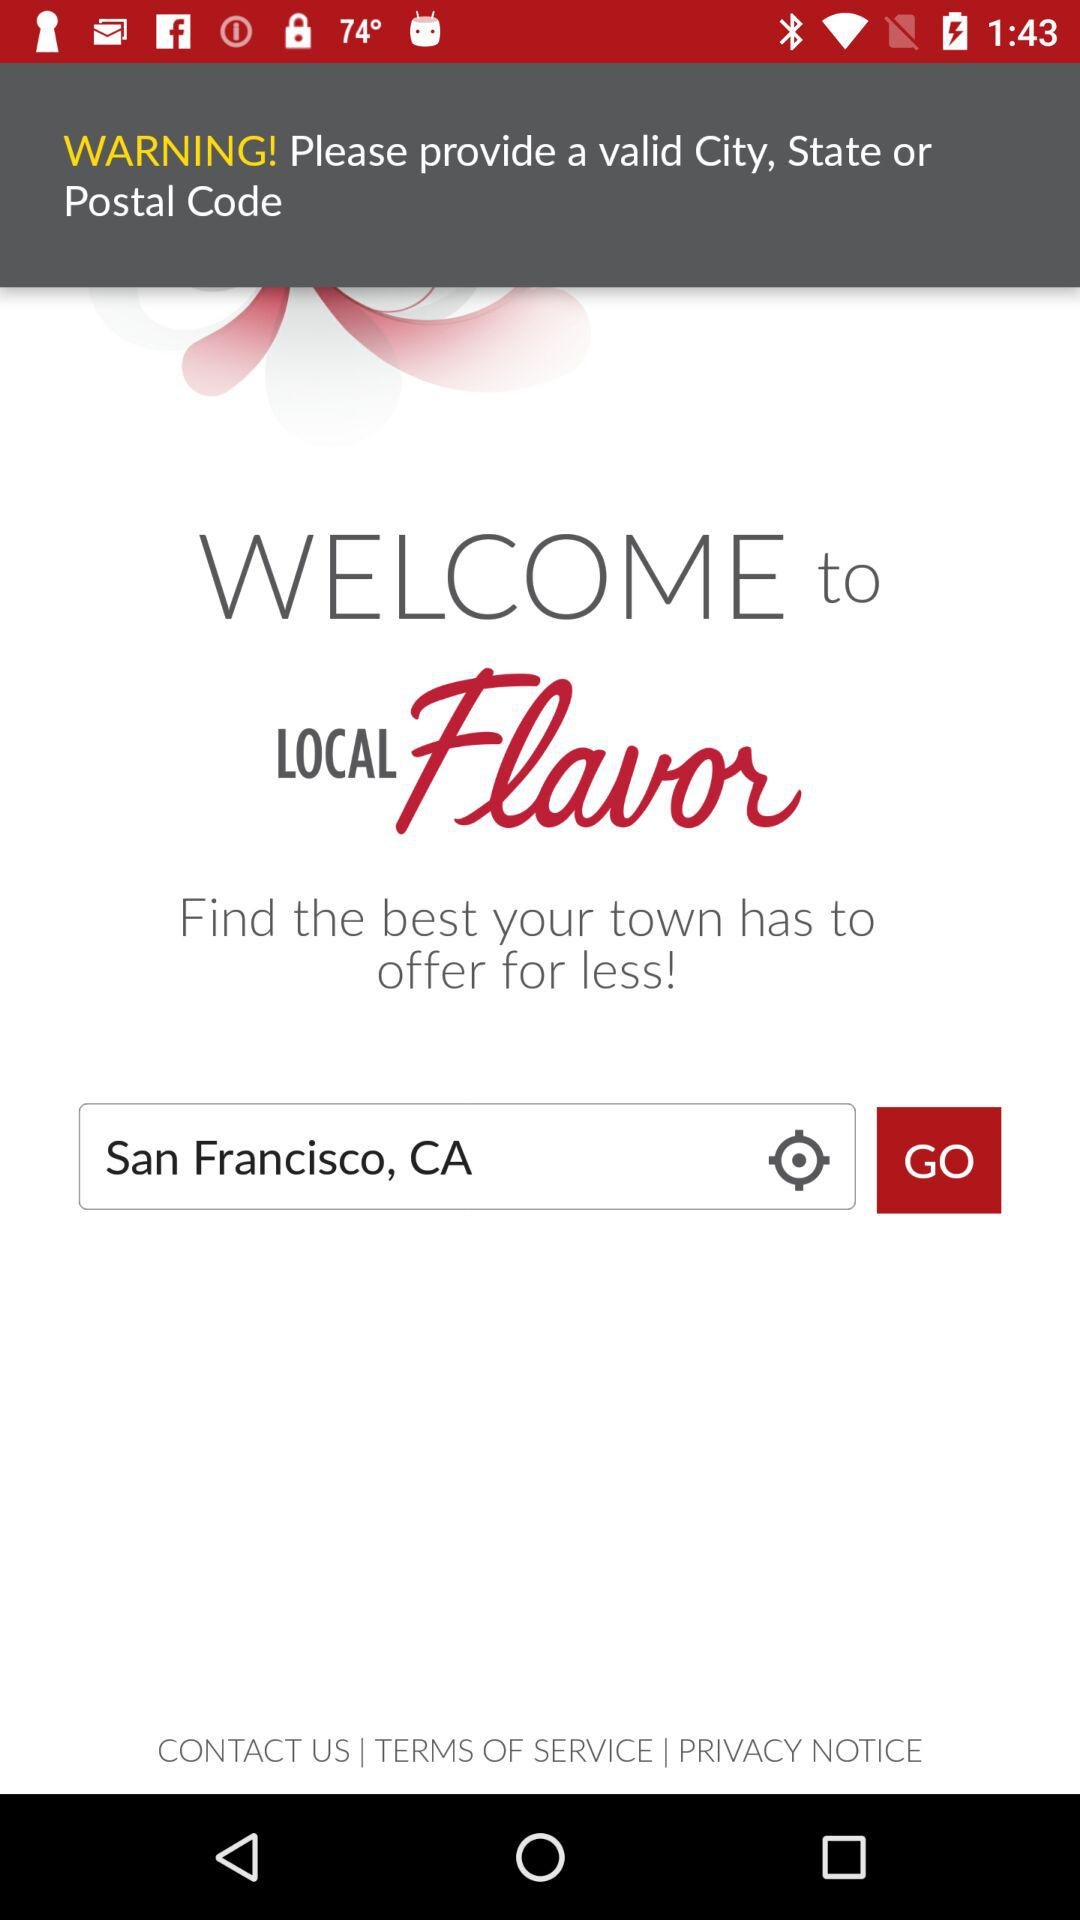What is the name of the application? The name of the application is "LOCAL Flavor". 